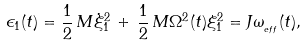<formula> <loc_0><loc_0><loc_500><loc_500>\epsilon _ { 1 } ( t ) = \frac { 1 } { 2 } \, M \dot { \xi } _ { 1 } ^ { 2 } \, + \, \frac { 1 } { 2 } \, M \Omega ^ { 2 } ( t ) \xi _ { 1 } ^ { 2 } = J \omega _ { _ { e f f } } ( t ) ,</formula> 